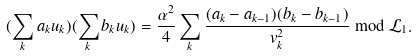Convert formula to latex. <formula><loc_0><loc_0><loc_500><loc_500>( \sum _ { k } a _ { k } u _ { k } ) ( \sum _ { k } b _ { k } u _ { k } ) = \frac { \alpha ^ { 2 } } { 4 } \sum _ { k } \frac { ( a _ { k } - a _ { k - 1 } ) ( b _ { k } - b _ { k - 1 } ) } { v ^ { 2 } _ { k } } \bmod \mathcal { L } _ { 1 } .</formula> 